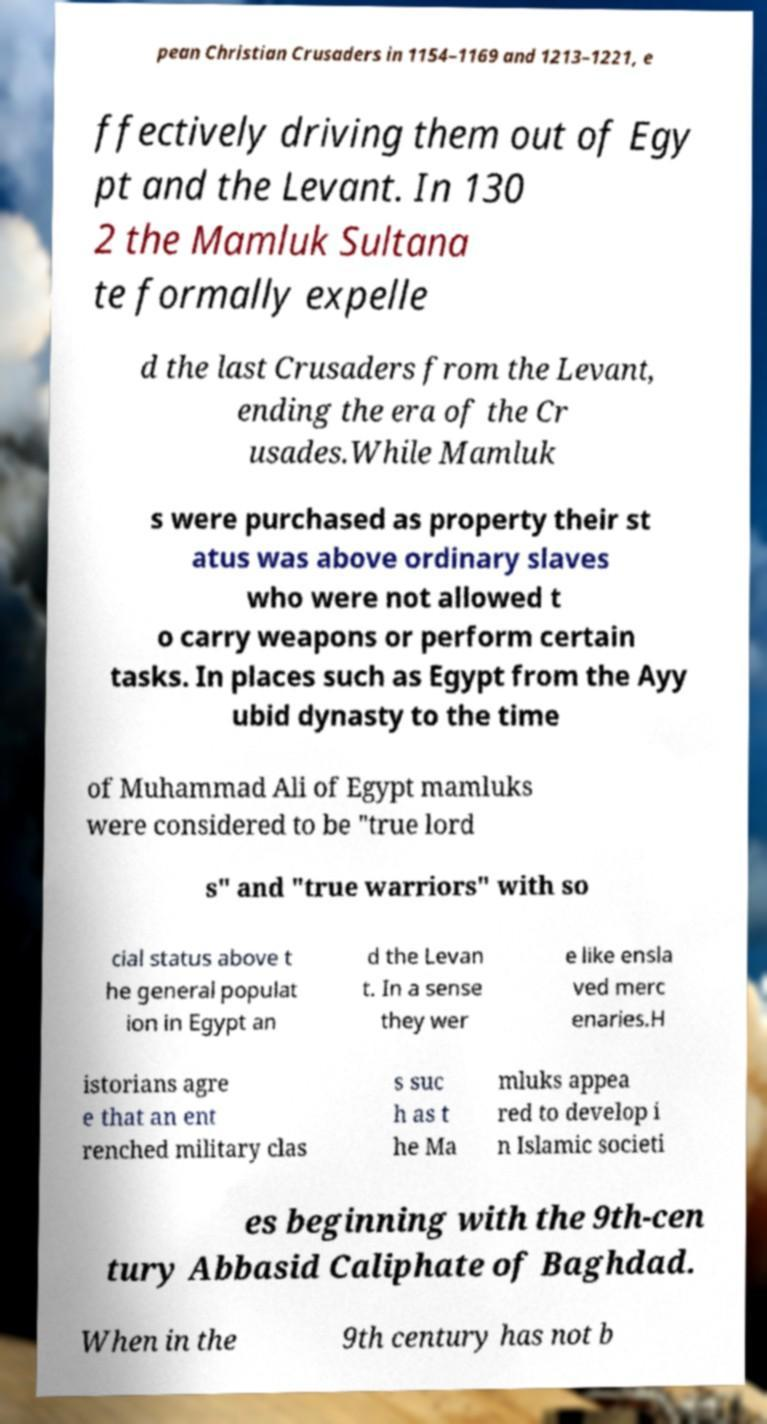I need the written content from this picture converted into text. Can you do that? pean Christian Crusaders in 1154–1169 and 1213–1221, e ffectively driving them out of Egy pt and the Levant. In 130 2 the Mamluk Sultana te formally expelle d the last Crusaders from the Levant, ending the era of the Cr usades.While Mamluk s were purchased as property their st atus was above ordinary slaves who were not allowed t o carry weapons or perform certain tasks. In places such as Egypt from the Ayy ubid dynasty to the time of Muhammad Ali of Egypt mamluks were considered to be "true lord s" and "true warriors" with so cial status above t he general populat ion in Egypt an d the Levan t. In a sense they wer e like ensla ved merc enaries.H istorians agre e that an ent renched military clas s suc h as t he Ma mluks appea red to develop i n Islamic societi es beginning with the 9th-cen tury Abbasid Caliphate of Baghdad. When in the 9th century has not b 